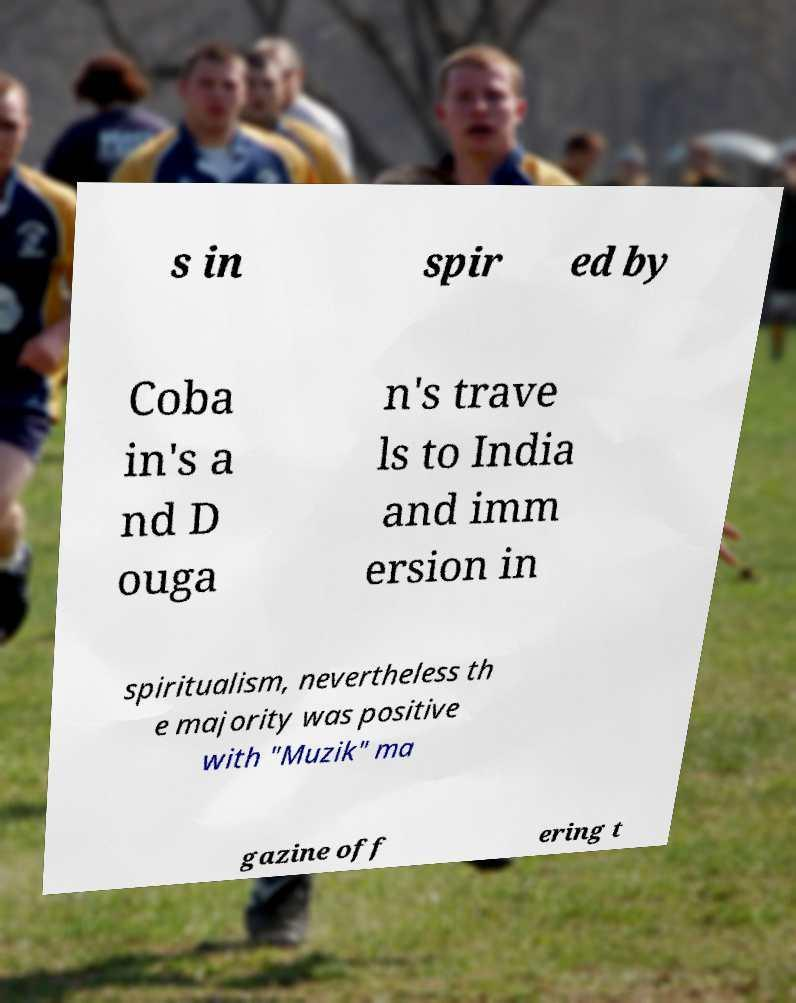There's text embedded in this image that I need extracted. Can you transcribe it verbatim? s in spir ed by Coba in's a nd D ouga n's trave ls to India and imm ersion in spiritualism, nevertheless th e majority was positive with "Muzik" ma gazine off ering t 